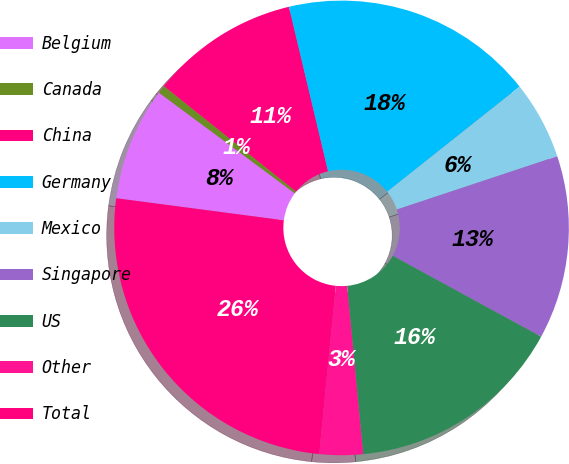<chart> <loc_0><loc_0><loc_500><loc_500><pie_chart><fcel>Belgium<fcel>Canada<fcel>China<fcel>Germany<fcel>Mexico<fcel>Singapore<fcel>US<fcel>Other<fcel>Total<nl><fcel>8.06%<fcel>0.58%<fcel>10.56%<fcel>18.04%<fcel>5.57%<fcel>13.05%<fcel>15.54%<fcel>3.08%<fcel>25.52%<nl></chart> 